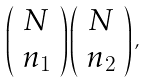<formula> <loc_0><loc_0><loc_500><loc_500>\left ( \begin{array} { c } N \\ n _ { 1 } \end{array} \right ) \left ( \begin{array} { c } N \\ n _ { 2 } \end{array} \right ) ,</formula> 